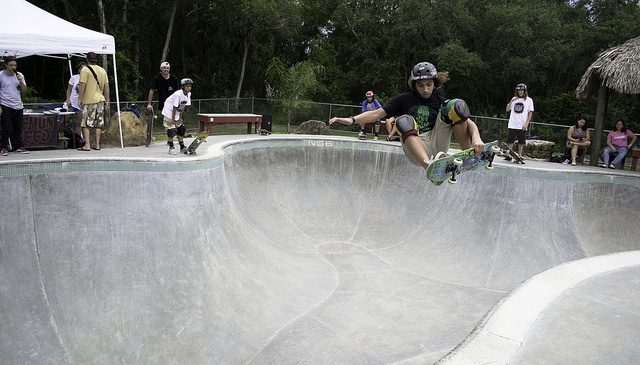Describe the objects in this image and their specific colors. I can see people in lavender, black, gray, and darkgray tones, people in lavender, black, darkgray, and gray tones, people in lavender, tan, gray, black, and darkgray tones, skateboard in lavender, gray, black, darkgray, and green tones, and people in lavender, black, gray, and darkgray tones in this image. 